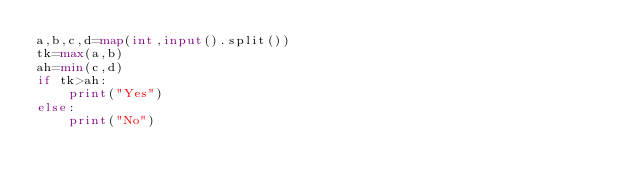<code> <loc_0><loc_0><loc_500><loc_500><_Python_>a,b,c,d=map(int,input().split())
tk=max(a,b)
ah=min(c,d)
if tk>ah:
    print("Yes")
else:
    print("No")
</code> 